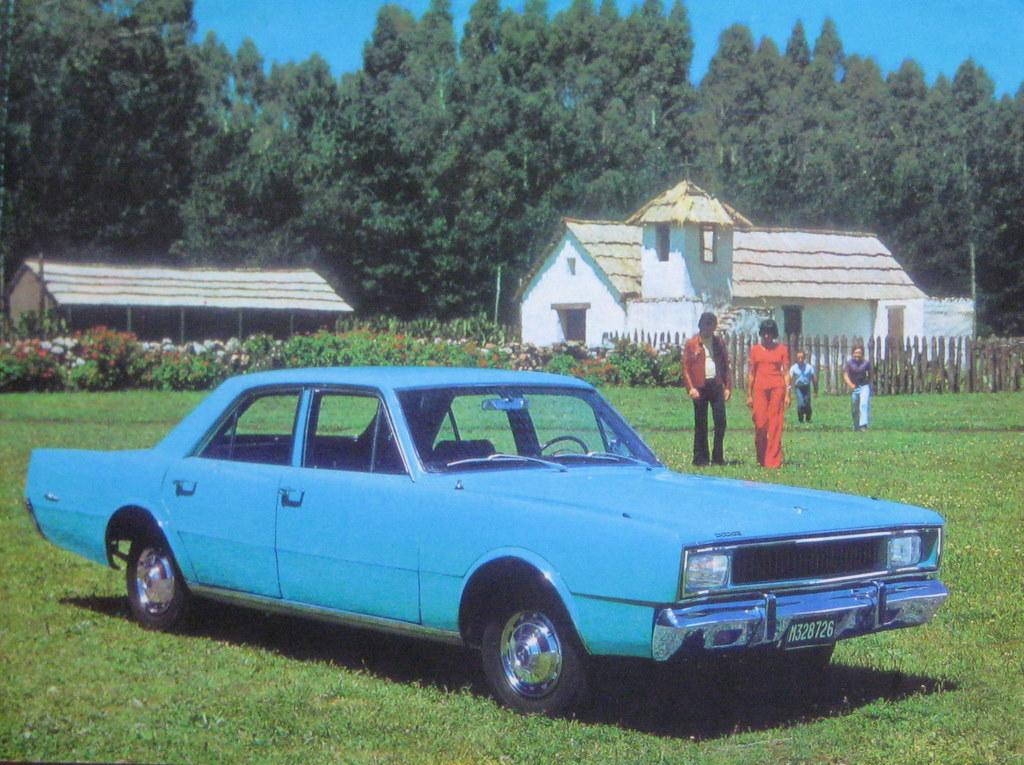What type of structures can be seen in the image? There are buildings with rooftops in the image. How many people are present in the image? There are four persons in the image. What mode of transportation can be seen in the image? There is a vehicle in the image. What type of vegetation is present in the image? Grass, plants, and trees are visible in the image. Are there any flowers in the image? Yes, flowers are present in the image. What type of fencing is visible in the image? There is wooden fencing in the image. What can be seen in the background of the image? The sky is visible in the background of the image. How many mice are running around on the rooftops in the image? There are no mice present in the image; only buildings with rooftops can be seen. Is it raining in the image? There is no indication of rain in the image; the sky is visible in the background, but no rain is depicted. 